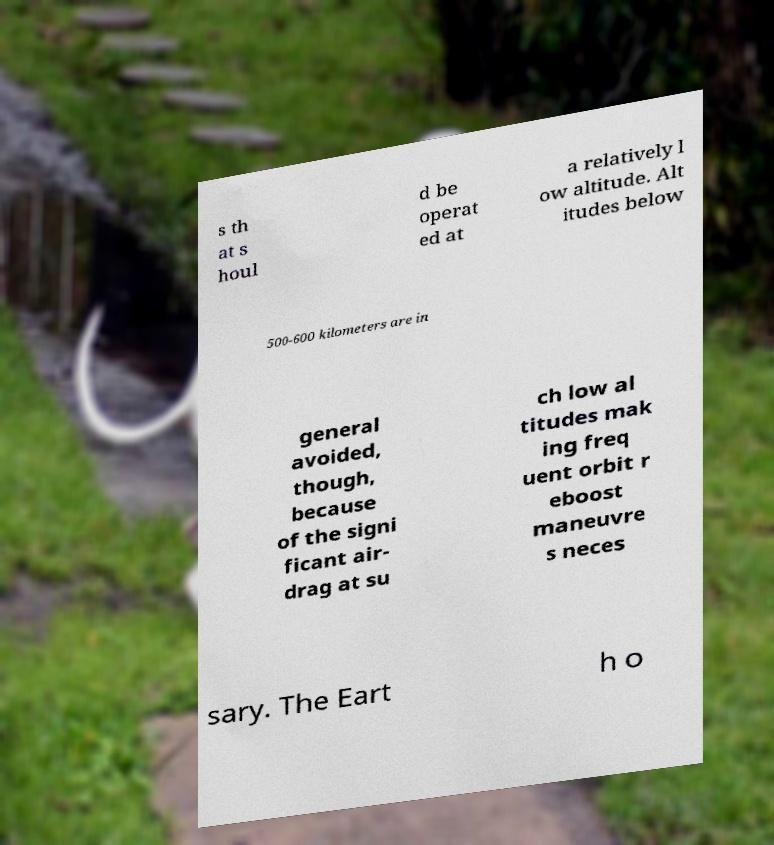There's text embedded in this image that I need extracted. Can you transcribe it verbatim? s th at s houl d be operat ed at a relatively l ow altitude. Alt itudes below 500-600 kilometers are in general avoided, though, because of the signi ficant air- drag at su ch low al titudes mak ing freq uent orbit r eboost maneuvre s neces sary. The Eart h o 